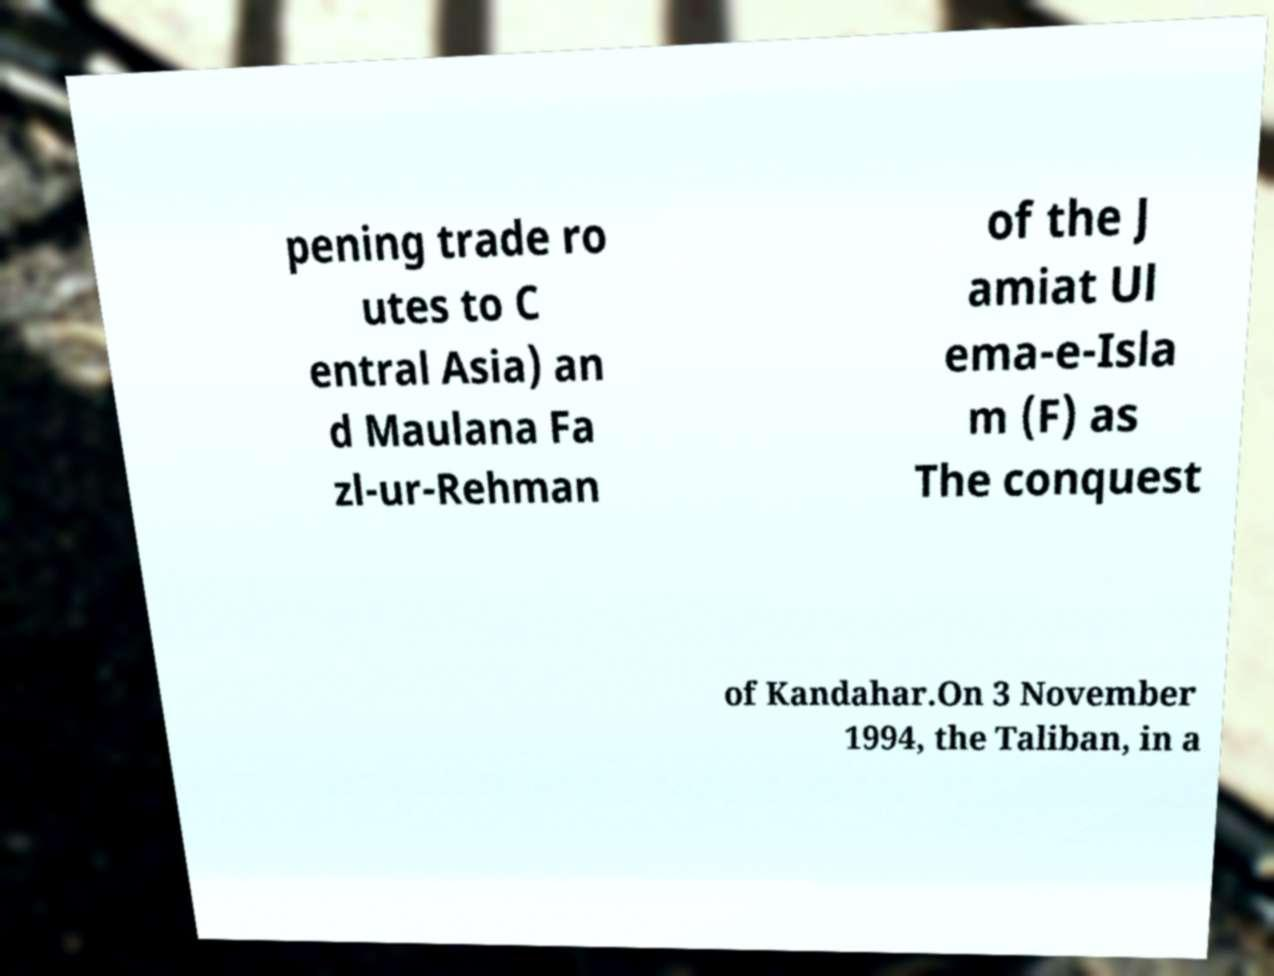Please read and relay the text visible in this image. What does it say? pening trade ro utes to C entral Asia) an d Maulana Fa zl-ur-Rehman of the J amiat Ul ema-e-Isla m (F) as The conquest of Kandahar.On 3 November 1994, the Taliban, in a 